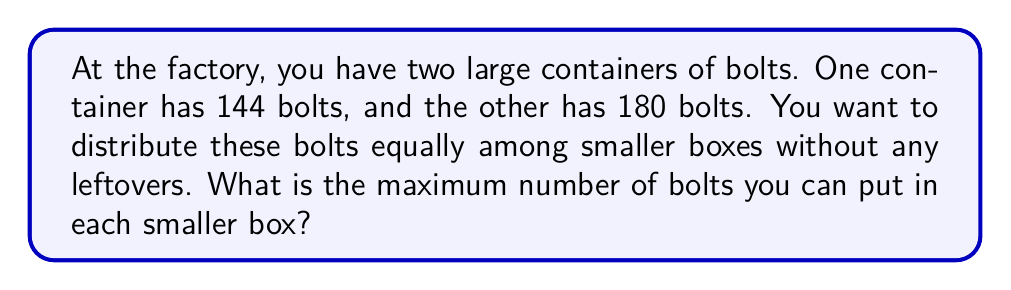What is the answer to this math problem? To solve this problem, we need to find the greatest common divisor (GCD) of 144 and 180. We can use the Euclidean algorithm:

1) First, divide 180 by 144:
   $180 = 1 \times 144 + 36$

2) Now divide 144 by 36:
   $144 = 4 \times 36 + 0$

3) The process stops when we get a remainder of 0. The last non-zero remainder (36) is the GCD.

Alternatively, we can factor the numbers:
$144 = 2^4 \times 3^2$
$180 = 2^2 \times 3^2 \times 5$

The GCD is the product of all common factors with their lowest exponents:
$GCD(144, 180) = 2^2 \times 3^2 = 4 \times 9 = 36$

Therefore, the maximum number of bolts that can be put in each smaller box is 36.
Answer: 36 